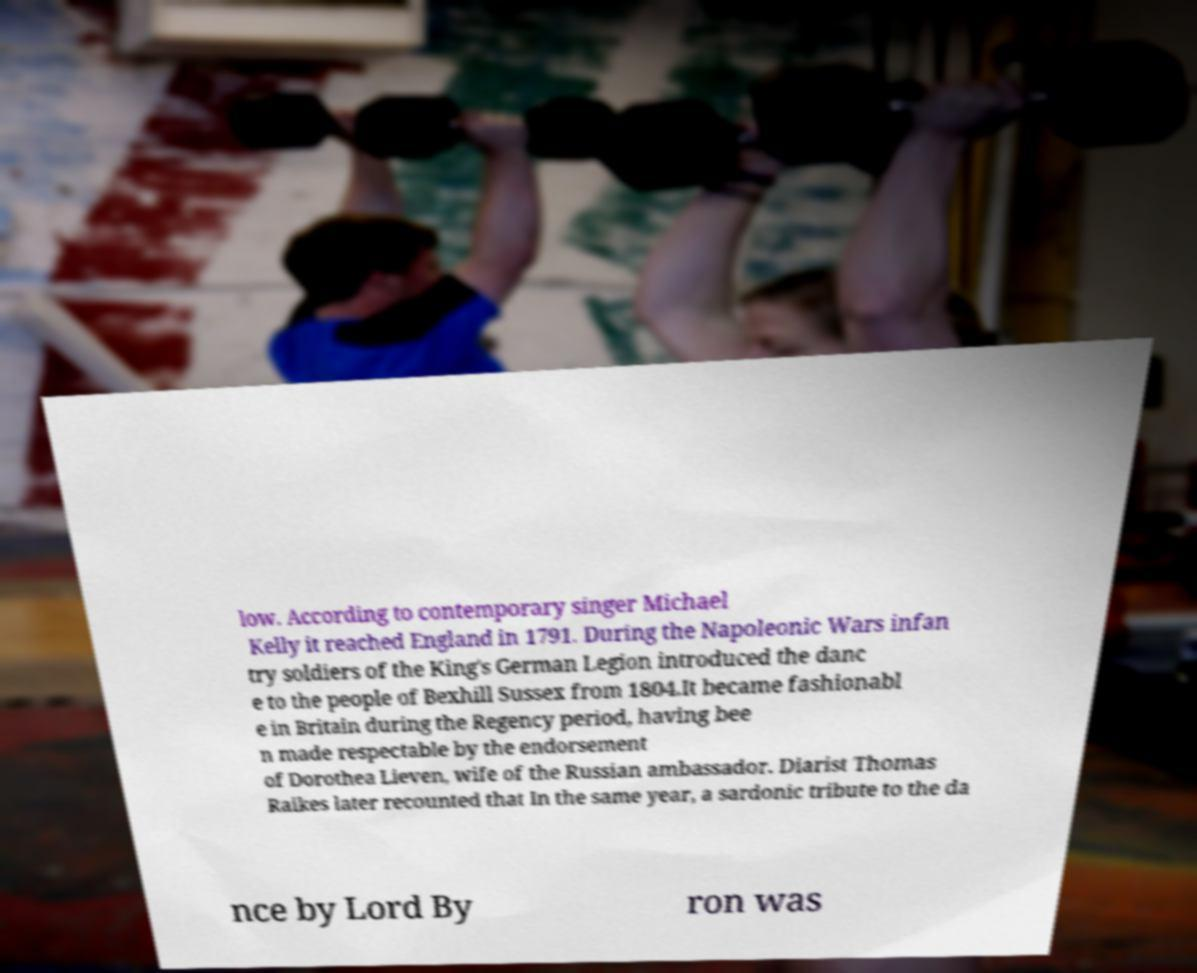Could you assist in decoding the text presented in this image and type it out clearly? low. According to contemporary singer Michael Kelly it reached England in 1791. During the Napoleonic Wars infan try soldiers of the King's German Legion introduced the danc e to the people of Bexhill Sussex from 1804.It became fashionabl e in Britain during the Regency period, having bee n made respectable by the endorsement of Dorothea Lieven, wife of the Russian ambassador. Diarist Thomas Raikes later recounted that In the same year, a sardonic tribute to the da nce by Lord By ron was 